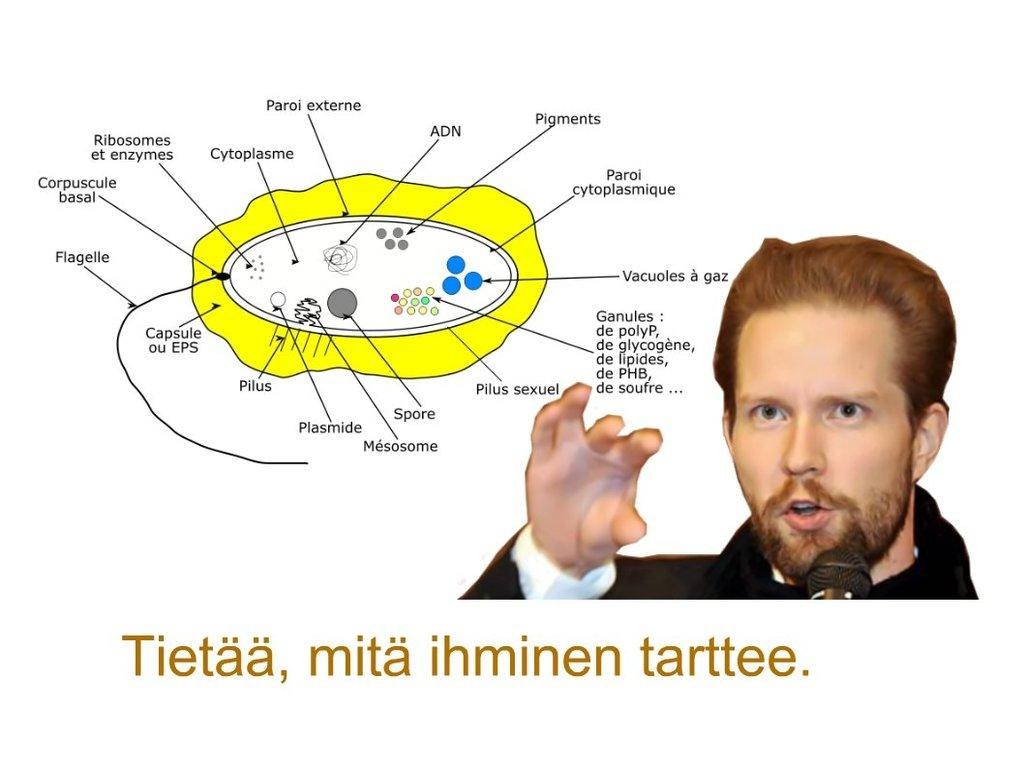What is the man on the right side of the image doing? The man is holding a microphone. What might the man be doing with the microphone? The man might be speaking or singing into the microphone. Can you describe any text visible in the image? There is some text visible in the image, but its content is not clear from the provided facts. What type of pet can be seen playing with the sink in the image? There is no pet or sink present in the image. Can you describe the bird that is perched on the man's shoulder in the image? There is no bird present in the image; the man is holding a microphone. 